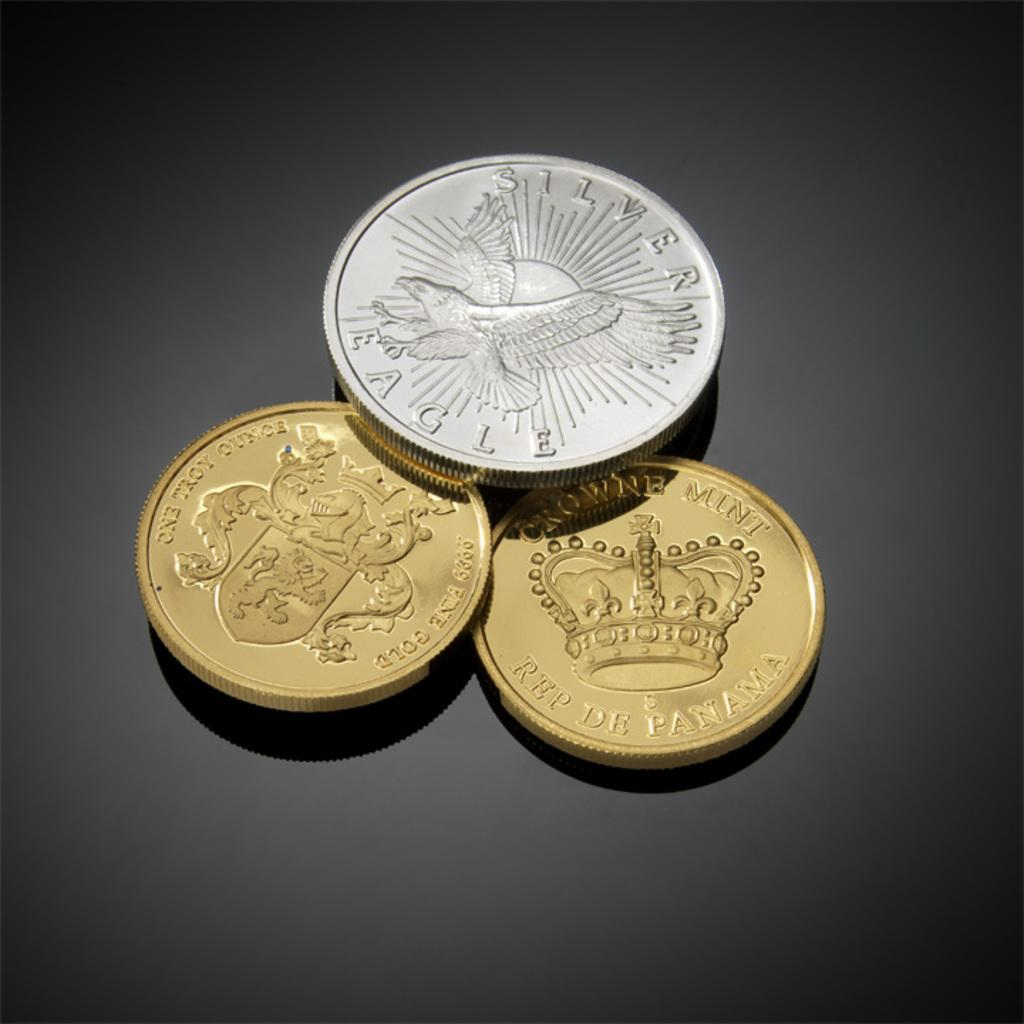Provide a one-sentence caption for the provided image. Three coins sit on table one is a silver eagle. 